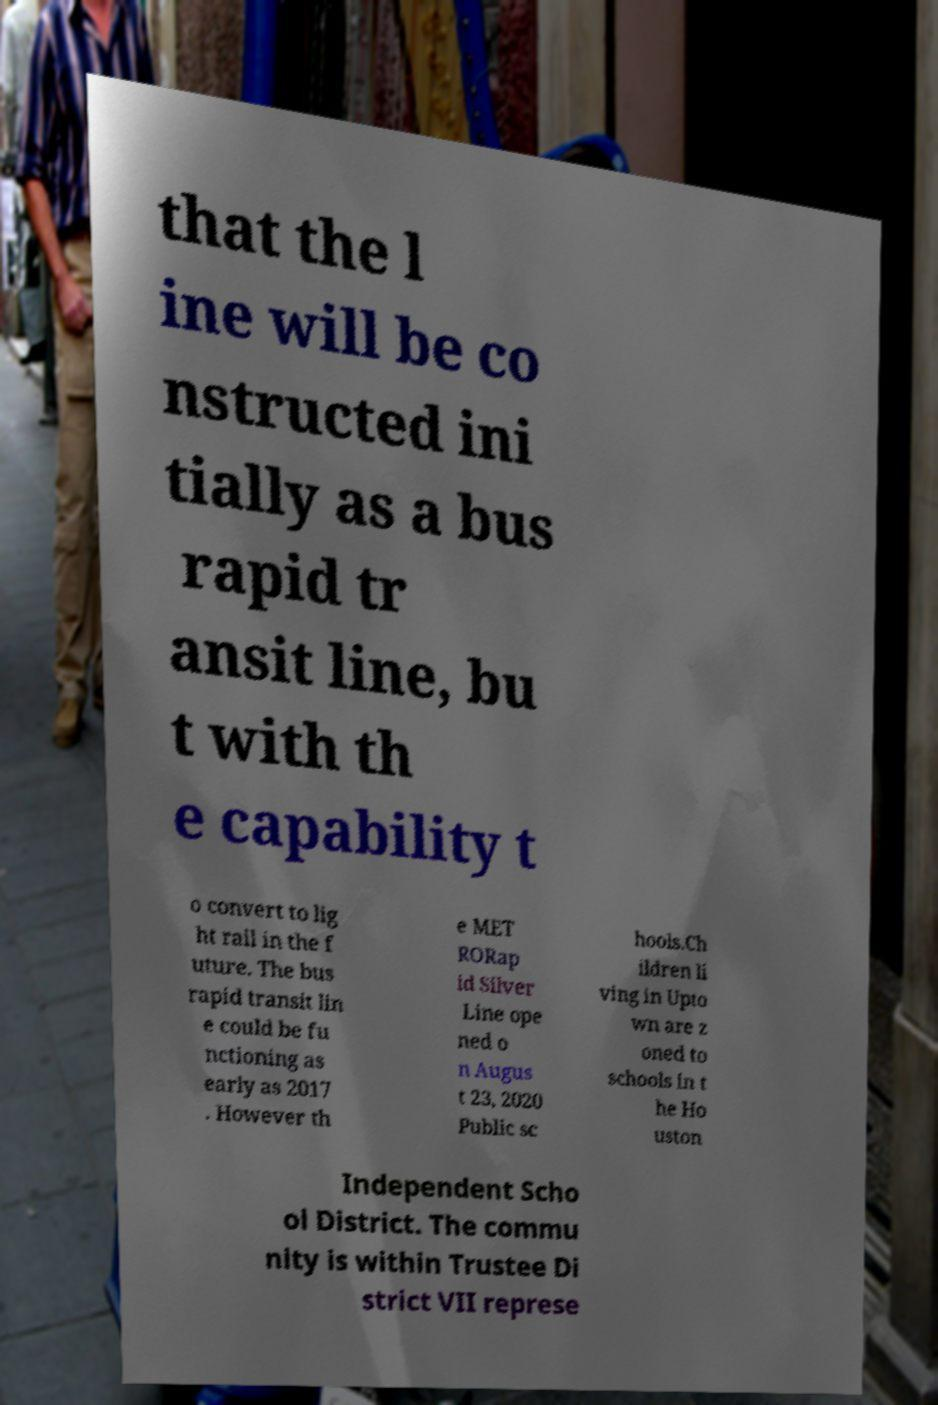Could you extract and type out the text from this image? that the l ine will be co nstructed ini tially as a bus rapid tr ansit line, bu t with th e capability t o convert to lig ht rail in the f uture. The bus rapid transit lin e could be fu nctioning as early as 2017 . However th e MET RORap id Silver Line ope ned o n Augus t 23, 2020 Public sc hools.Ch ildren li ving in Upto wn are z oned to schools in t he Ho uston Independent Scho ol District. The commu nity is within Trustee Di strict VII represe 